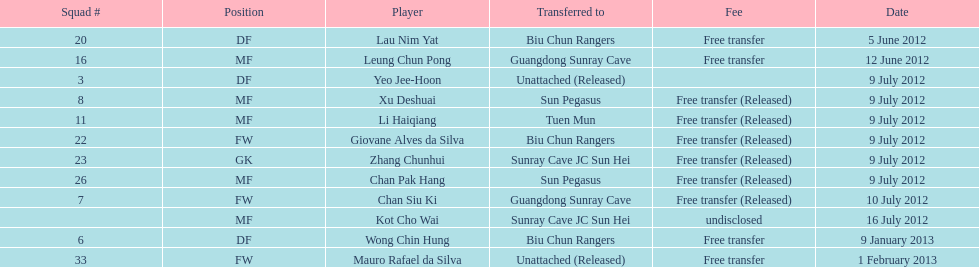For which position were li haiqiang and xu deshuai both known to play? MF. 